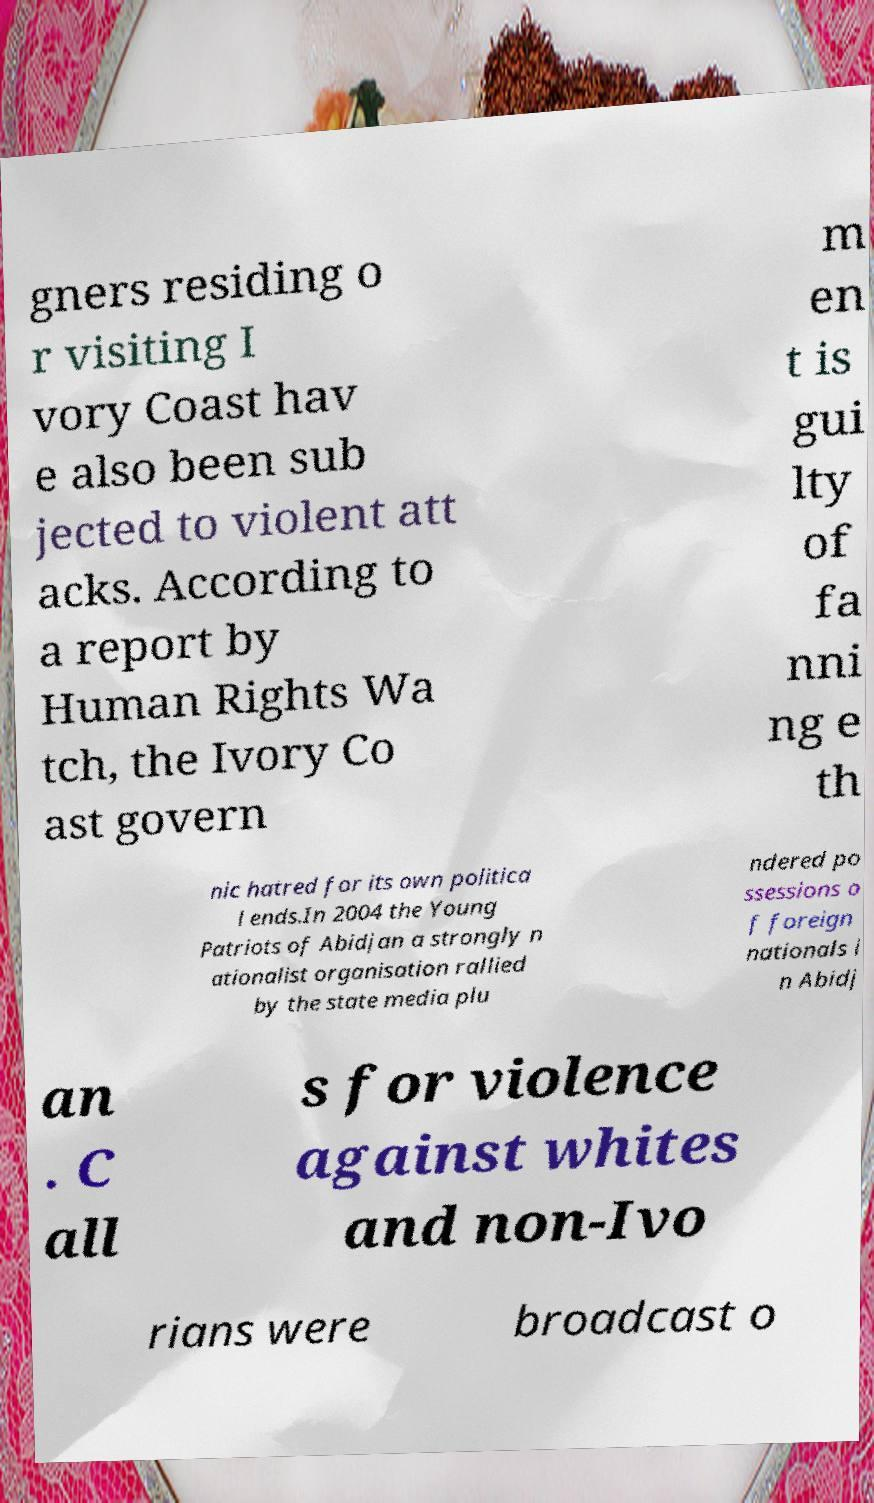There's text embedded in this image that I need extracted. Can you transcribe it verbatim? gners residing o r visiting I vory Coast hav e also been sub jected to violent att acks. According to a report by Human Rights Wa tch, the Ivory Co ast govern m en t is gui lty of fa nni ng e th nic hatred for its own politica l ends.In 2004 the Young Patriots of Abidjan a strongly n ationalist organisation rallied by the state media plu ndered po ssessions o f foreign nationals i n Abidj an . C all s for violence against whites and non-Ivo rians were broadcast o 